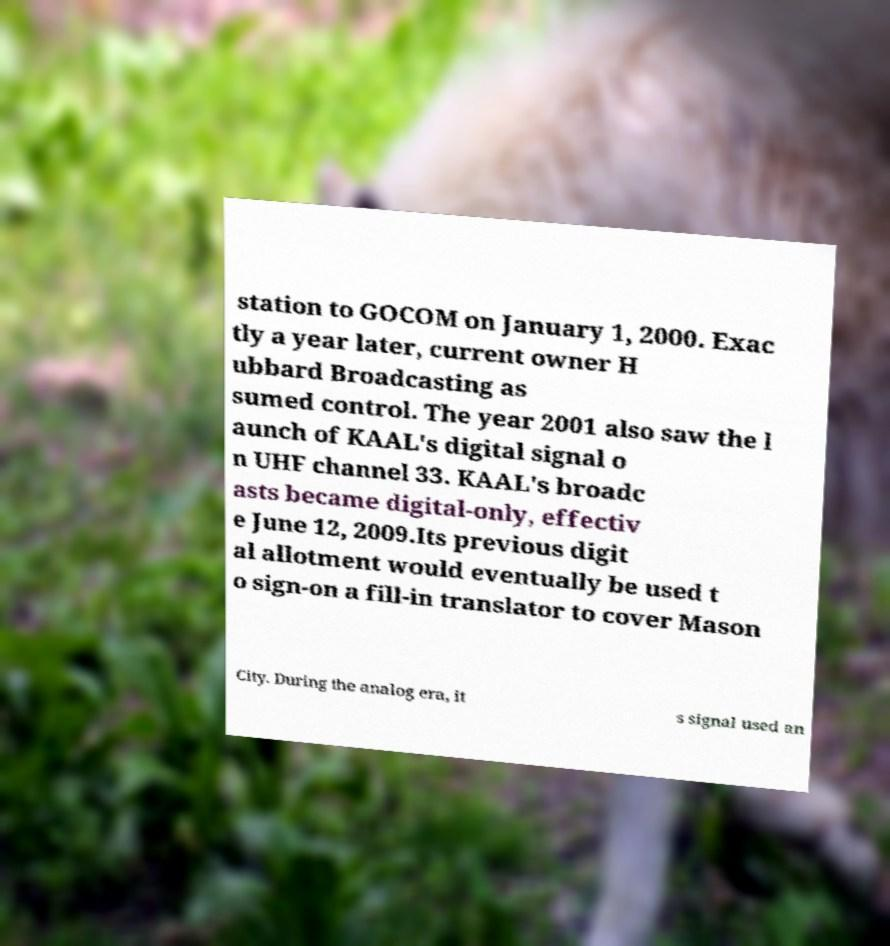There's text embedded in this image that I need extracted. Can you transcribe it verbatim? station to GOCOM on January 1, 2000. Exac tly a year later, current owner H ubbard Broadcasting as sumed control. The year 2001 also saw the l aunch of KAAL's digital signal o n UHF channel 33. KAAL's broadc asts became digital-only, effectiv e June 12, 2009.Its previous digit al allotment would eventually be used t o sign-on a fill-in translator to cover Mason City. During the analog era, it s signal used an 